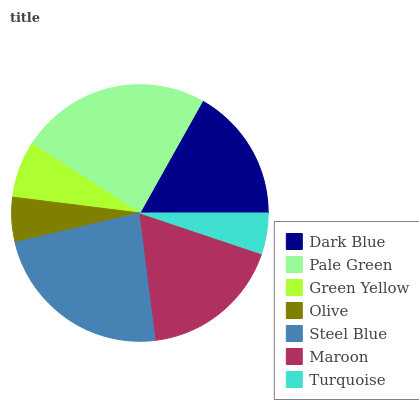Is Turquoise the minimum?
Answer yes or no. Yes. Is Pale Green the maximum?
Answer yes or no. Yes. Is Green Yellow the minimum?
Answer yes or no. No. Is Green Yellow the maximum?
Answer yes or no. No. Is Pale Green greater than Green Yellow?
Answer yes or no. Yes. Is Green Yellow less than Pale Green?
Answer yes or no. Yes. Is Green Yellow greater than Pale Green?
Answer yes or no. No. Is Pale Green less than Green Yellow?
Answer yes or no. No. Is Dark Blue the high median?
Answer yes or no. Yes. Is Dark Blue the low median?
Answer yes or no. Yes. Is Pale Green the high median?
Answer yes or no. No. Is Green Yellow the low median?
Answer yes or no. No. 